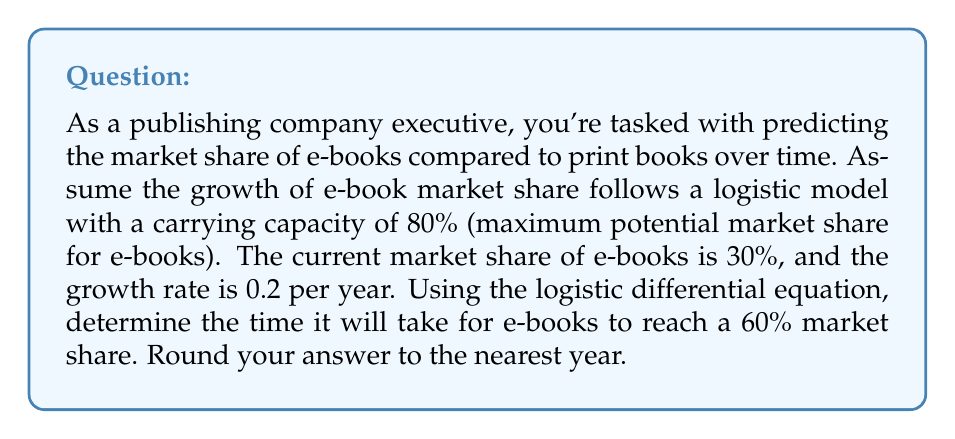Can you solve this math problem? Let's approach this step-by-step using the logistic differential equation:

1) The logistic differential equation is given by:

   $$\frac{dP}{dt} = rP(1 - \frac{P}{K})$$

   Where:
   $P$ is the population (in this case, market share)
   $t$ is time
   $r$ is the growth rate
   $K$ is the carrying capacity

2) We're given:
   $r = 0.2$ per year
   $K = 80\%$ or 0.8
   Initial $P_0 = 30\%$ or 0.3
   We want to find when $P = 60\%$ or 0.6

3) The solution to the logistic differential equation is:

   $$P(t) = \frac{K}{1 + (\frac{K}{P_0} - 1)e^{-rt}}$$

4) Substituting our values:

   $$0.6 = \frac{0.8}{1 + (\frac{0.8}{0.3} - 1)e^{-0.2t}}$$

5) Solving for $t$:
   
   $$1 + (\frac{0.8}{0.3} - 1)e^{-0.2t} = \frac{0.8}{0.6}$$
   
   $$(\frac{0.8}{0.3} - 1)e^{-0.2t} = \frac{0.8}{0.6} - 1$$
   
   $$e^{-0.2t} = \frac{\frac{0.8}{0.6} - 1}{\frac{0.8}{0.3} - 1} = \frac{1/3}{8/3 - 1} = \frac{1/3}{5/3} = \frac{1}{5}$$
   
   $$-0.2t = \ln(\frac{1}{5})$$
   
   $$t = -\frac{\ln(\frac{1}{5})}{0.2} \approx 8.05$$

6) Rounding to the nearest year, we get 8 years.
Answer: It will take approximately 8 years for e-books to reach a 60% market share. 